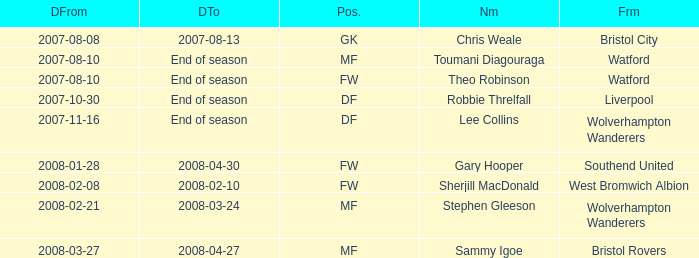What was the name for the row with Date From of 2008-02-21? Stephen Gleeson. 